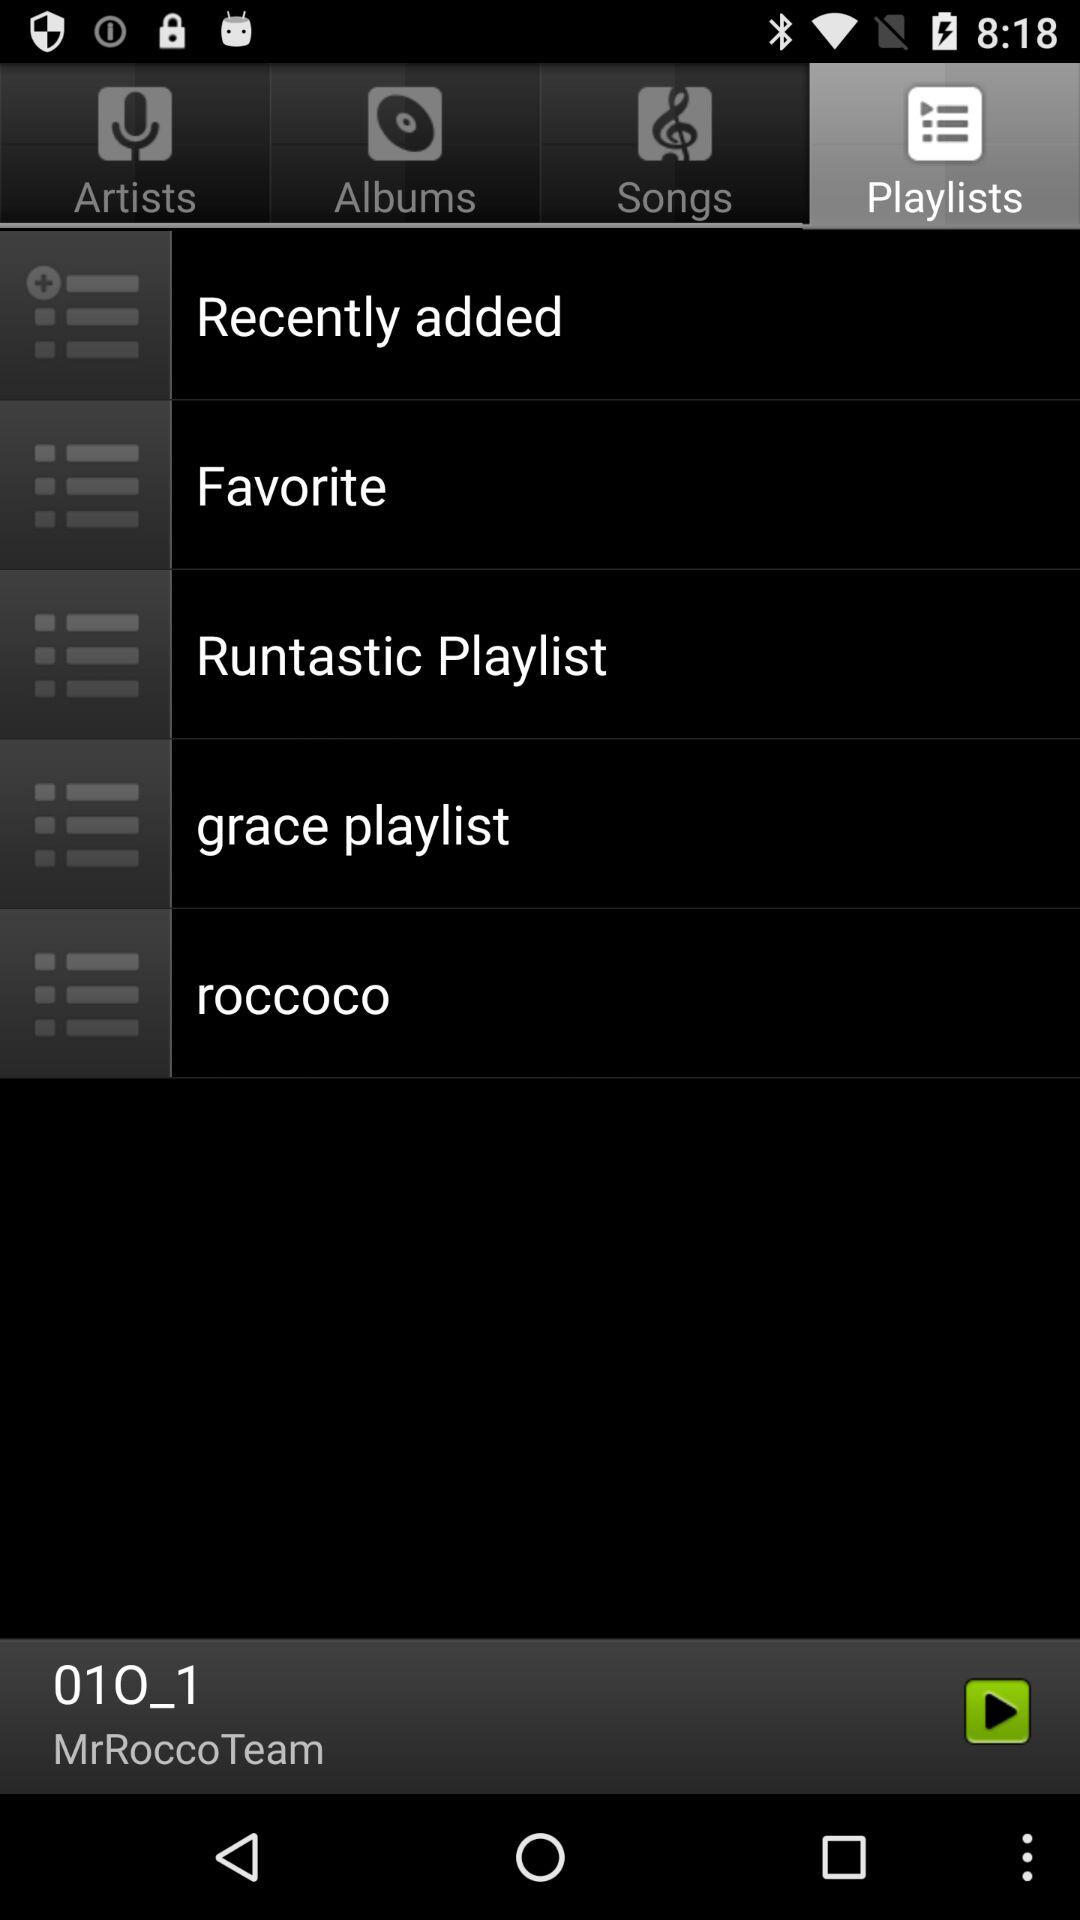Who is the composer of the audio "01O_1"? The composer is "MrRoccoTeam". 